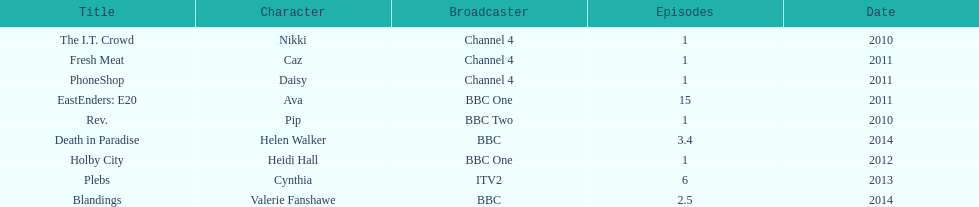Blandings and death in paradise both aired on which broadcaster? BBC. 